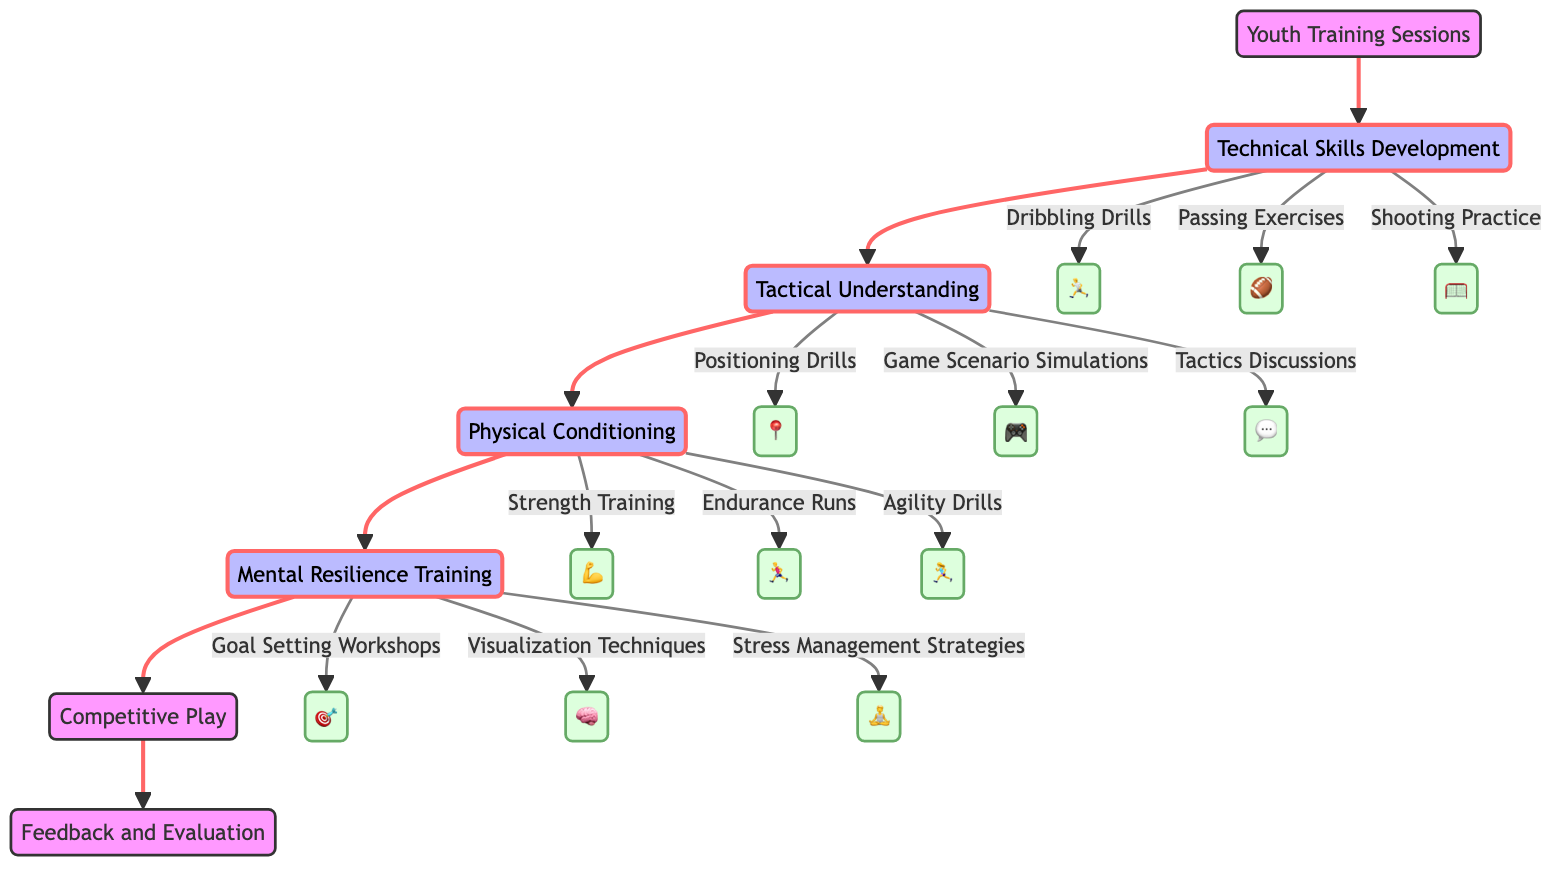What is the starting point of the Player Development Pathway? The diagram indicates that the starting point is labeled "Youth Training Sessions." This is visually represented at the top of the flow chart.
Answer: Youth Training Sessions How many stages are there before Competitive Play? The diagram shows a total of four stages leading up to Competitive Play: Technical Skills Development, Tactical Understanding, Physical Conditioning, and Mental Resilience Training. Counting these stages provides the answer.
Answer: 4 What activities are associated with Technical Skills Development? The flow chart specifies three activities under the Technical Skills Development stage: Dribbling Drills, Passing Exercises, and Shooting Practice. These can be directly read from the diagram.
Answer: Dribbling Drills, Passing Exercises, Shooting Practice Which stage comes after Tactical Understanding? By examining the flow of the diagram, it shows that Physical Conditioning directly follows Tactical Understanding as the next stage in the Player Development Pathway.
Answer: Physical Conditioning What type of training is emphasized for Mental Resilience? In the diagram, three activities are specifically listed under Mental Resilience Training: Goal Setting Workshops, Visualization Techniques, and Stress Management Strategies. This indicates a focus on mental aspects of training.
Answer: Goal Setting Workshops, Visualization Techniques, Stress Management Strategies What is the final stage of the Player Development Pathway? As per the flowchart, the last stage before reaching the endpoint is Competitive Play, which is positioned right before the end node indicating feedback and evaluation.
Answer: Competitive Play How does the flow of the diagram connect Technical Skills Development to Competitive Play? The diagram represents a sequential progression from Technical Skills Development to Tactical Understanding, then to Physical Conditioning, followed by Mental Resilience Training, and finally leading to Competitive Play. This shows the linear progression of skill development.
Answer: Through four stages What is the purpose of the endpoint labeled "Feedback and Evaluation"? The endpoint in the diagram serves to conclude the Player Development Pathway, indicating that after Competitive Play, there will be a review process where progress and performance can be evaluated. This is an important aspect of overall player development.
Answer: Review process 